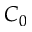<formula> <loc_0><loc_0><loc_500><loc_500>C _ { 0 }</formula> 